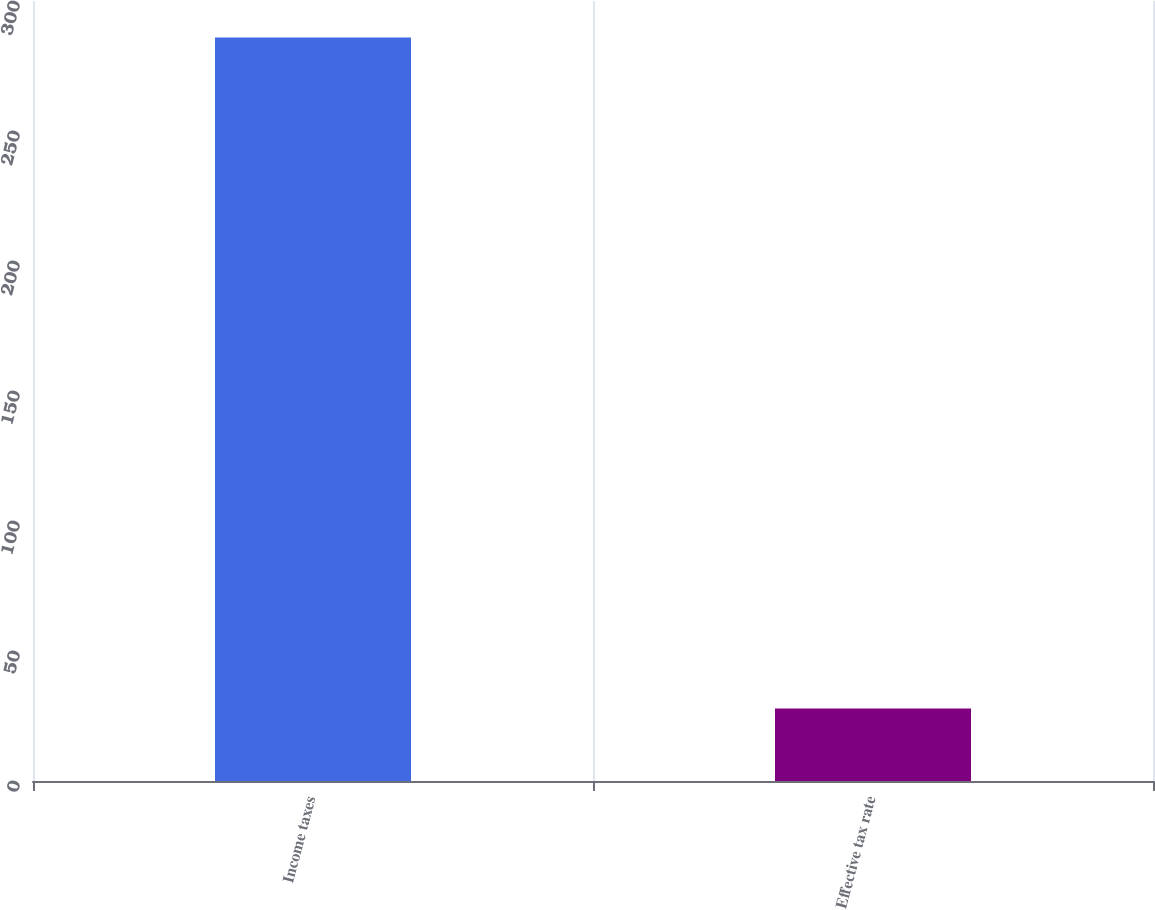Convert chart. <chart><loc_0><loc_0><loc_500><loc_500><bar_chart><fcel>Income taxes<fcel>Effective tax rate<nl><fcel>286<fcel>27.9<nl></chart> 